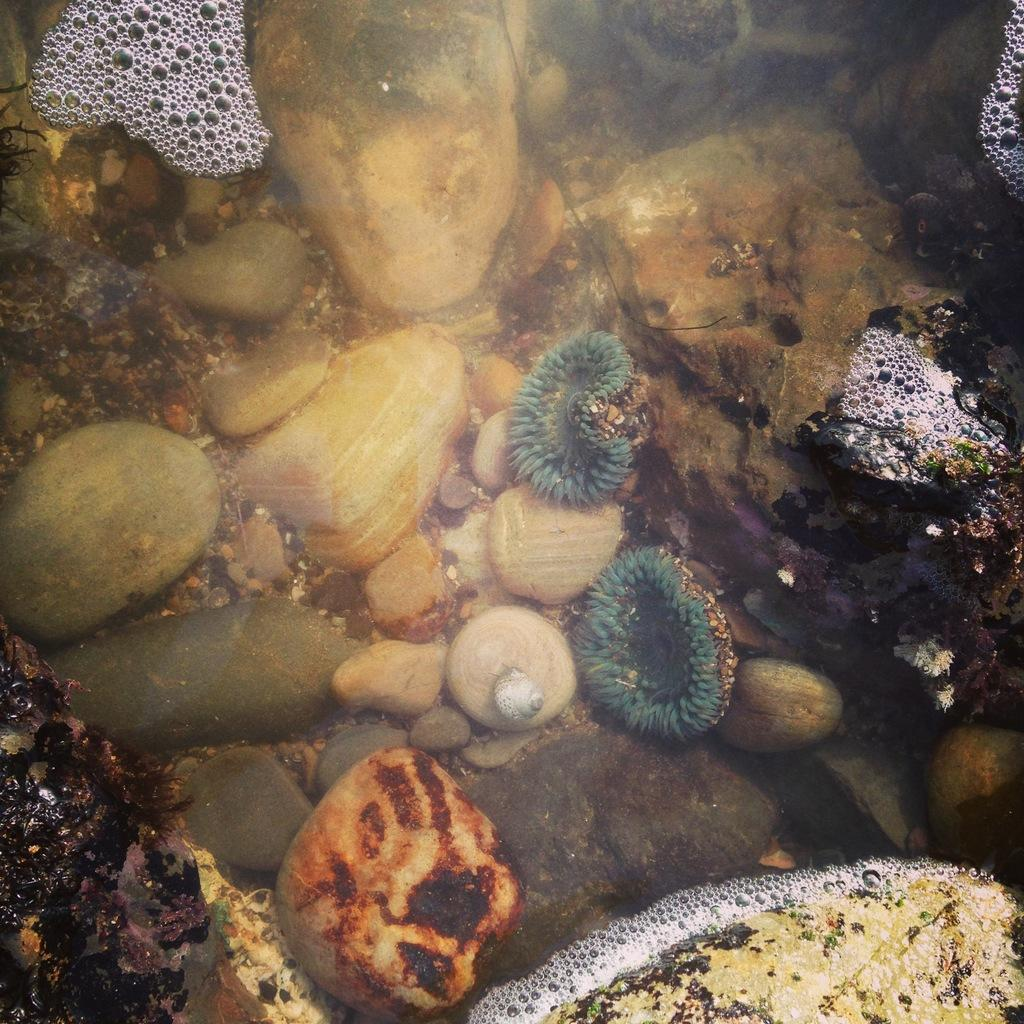What is present in the water in the image? There are stones and moss in the water. What can be seen on the surface of the water? There are bubbles with foam on the top of the water. What type of sack is being used to distribute the moss in the image? There is no sack present in the image, nor is there any distribution of moss taking place. 